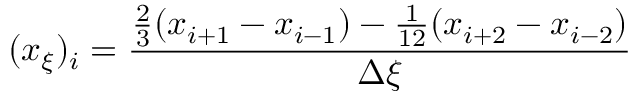Convert formula to latex. <formula><loc_0><loc_0><loc_500><loc_500>( x _ { \xi } ) _ { i } = \frac { \frac { 2 } { 3 } ( x _ { i + 1 } - x _ { i - 1 } ) - \frac { 1 } { 1 2 } ( x _ { i + 2 } - x _ { i - 2 } ) } { \Delta \xi }</formula> 